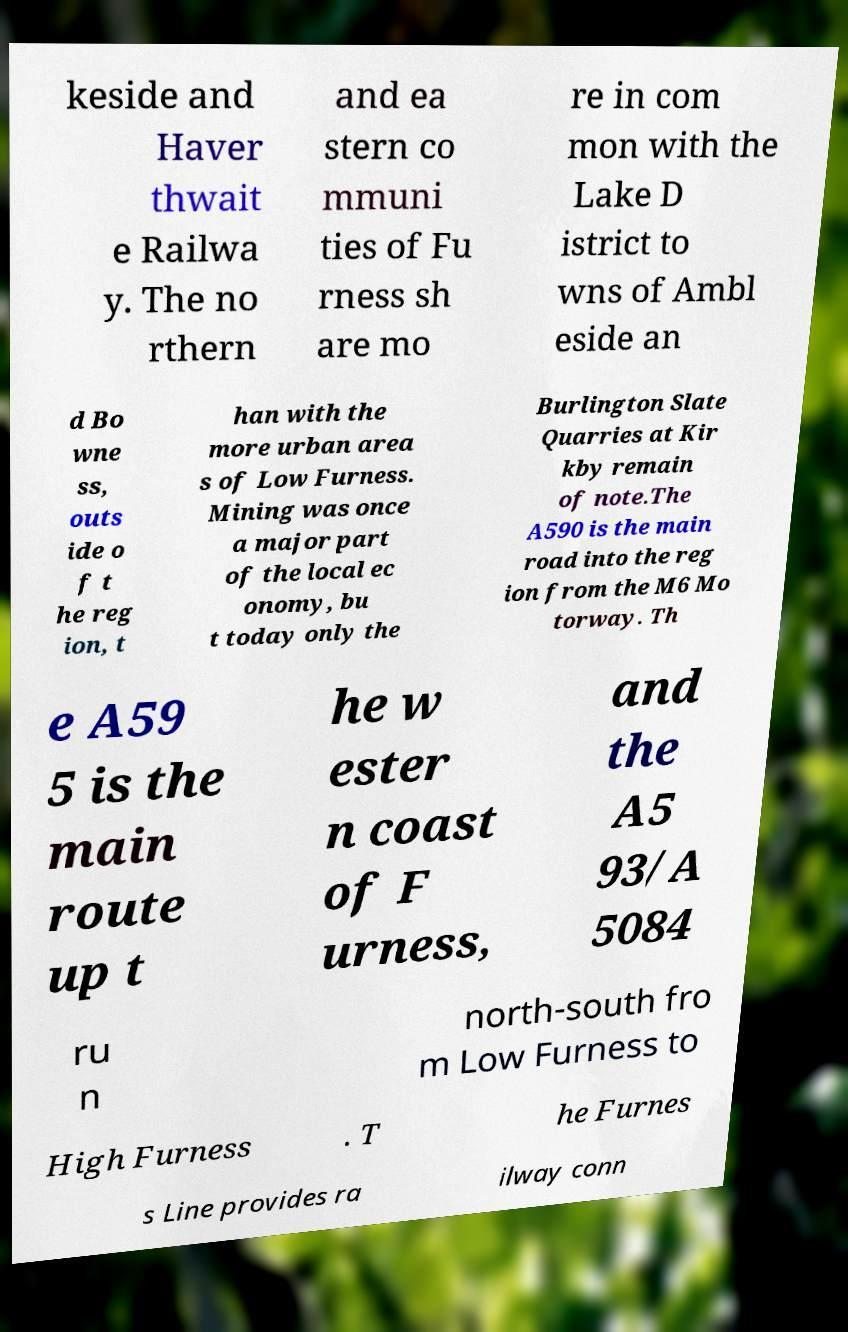Can you read and provide the text displayed in the image?This photo seems to have some interesting text. Can you extract and type it out for me? keside and Haver thwait e Railwa y. The no rthern and ea stern co mmuni ties of Fu rness sh are mo re in com mon with the Lake D istrict to wns of Ambl eside an d Bo wne ss, outs ide o f t he reg ion, t han with the more urban area s of Low Furness. Mining was once a major part of the local ec onomy, bu t today only the Burlington Slate Quarries at Kir kby remain of note.The A590 is the main road into the reg ion from the M6 Mo torway. Th e A59 5 is the main route up t he w ester n coast of F urness, and the A5 93/A 5084 ru n north-south fro m Low Furness to High Furness . T he Furnes s Line provides ra ilway conn 